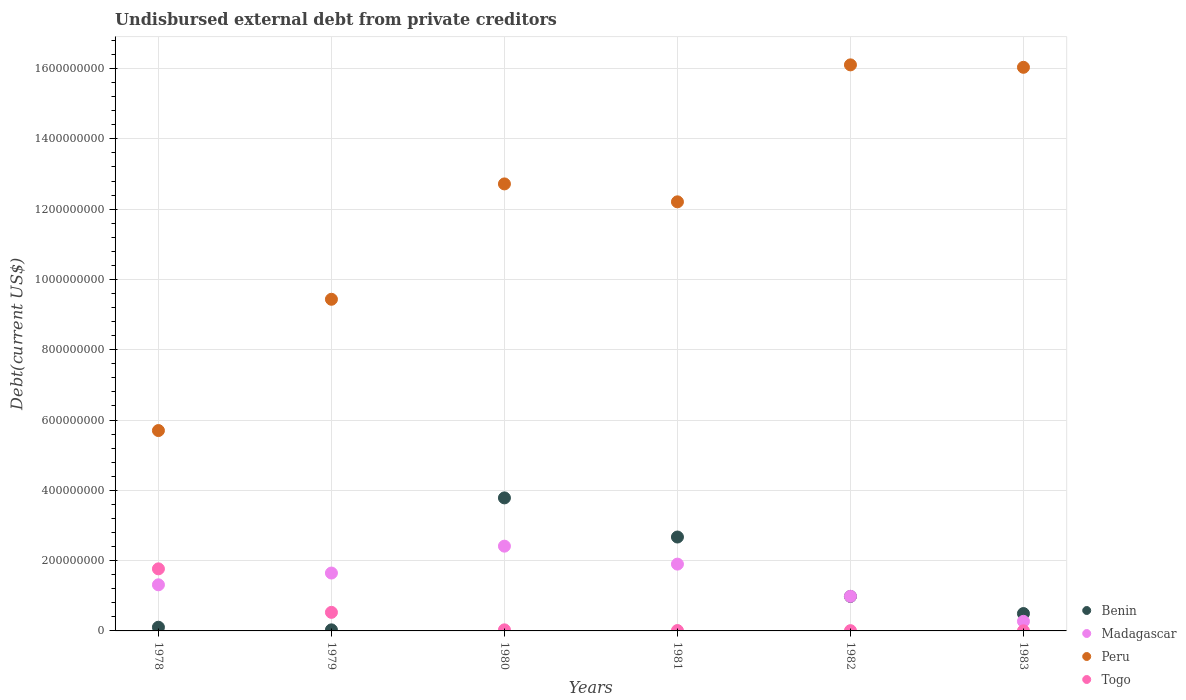How many different coloured dotlines are there?
Give a very brief answer. 4. What is the total debt in Togo in 1978?
Your answer should be compact. 1.77e+08. Across all years, what is the maximum total debt in Benin?
Your response must be concise. 3.78e+08. Across all years, what is the minimum total debt in Peru?
Your answer should be very brief. 5.70e+08. In which year was the total debt in Togo maximum?
Make the answer very short. 1978. In which year was the total debt in Madagascar minimum?
Offer a very short reply. 1983. What is the total total debt in Togo in the graph?
Offer a terse response. 2.35e+08. What is the difference between the total debt in Peru in 1979 and that in 1981?
Give a very brief answer. -2.77e+08. What is the difference between the total debt in Madagascar in 1983 and the total debt in Benin in 1981?
Your response must be concise. -2.40e+08. What is the average total debt in Benin per year?
Your response must be concise. 1.34e+08. In the year 1982, what is the difference between the total debt in Togo and total debt in Peru?
Make the answer very short. -1.61e+09. In how many years, is the total debt in Togo greater than 40000000 US$?
Offer a terse response. 2. What is the ratio of the total debt in Peru in 1978 to that in 1981?
Ensure brevity in your answer.  0.47. Is the total debt in Togo in 1978 less than that in 1979?
Offer a very short reply. No. Is the difference between the total debt in Togo in 1979 and 1983 greater than the difference between the total debt in Peru in 1979 and 1983?
Provide a short and direct response. Yes. What is the difference between the highest and the second highest total debt in Togo?
Your answer should be compact. 1.24e+08. What is the difference between the highest and the lowest total debt in Benin?
Offer a very short reply. 3.75e+08. Is the sum of the total debt in Madagascar in 1978 and 1982 greater than the maximum total debt in Peru across all years?
Ensure brevity in your answer.  No. Is it the case that in every year, the sum of the total debt in Madagascar and total debt in Togo  is greater than the sum of total debt in Peru and total debt in Benin?
Offer a terse response. No. Is it the case that in every year, the sum of the total debt in Togo and total debt in Madagascar  is greater than the total debt in Peru?
Your response must be concise. No. Is the total debt in Togo strictly less than the total debt in Madagascar over the years?
Offer a very short reply. No. What is the difference between two consecutive major ticks on the Y-axis?
Offer a very short reply. 2.00e+08. Are the values on the major ticks of Y-axis written in scientific E-notation?
Your response must be concise. No. How are the legend labels stacked?
Provide a succinct answer. Vertical. What is the title of the graph?
Your answer should be very brief. Undisbursed external debt from private creditors. What is the label or title of the Y-axis?
Your answer should be very brief. Debt(current US$). What is the Debt(current US$) in Benin in 1978?
Offer a very short reply. 1.05e+07. What is the Debt(current US$) in Madagascar in 1978?
Your answer should be very brief. 1.31e+08. What is the Debt(current US$) in Peru in 1978?
Your answer should be very brief. 5.70e+08. What is the Debt(current US$) of Togo in 1978?
Your answer should be very brief. 1.77e+08. What is the Debt(current US$) of Benin in 1979?
Offer a terse response. 3.05e+06. What is the Debt(current US$) in Madagascar in 1979?
Your response must be concise. 1.65e+08. What is the Debt(current US$) in Peru in 1979?
Provide a succinct answer. 9.44e+08. What is the Debt(current US$) in Togo in 1979?
Give a very brief answer. 5.28e+07. What is the Debt(current US$) of Benin in 1980?
Your answer should be very brief. 3.78e+08. What is the Debt(current US$) of Madagascar in 1980?
Make the answer very short. 2.41e+08. What is the Debt(current US$) in Peru in 1980?
Provide a short and direct response. 1.27e+09. What is the Debt(current US$) in Togo in 1980?
Offer a terse response. 3.05e+06. What is the Debt(current US$) in Benin in 1981?
Keep it short and to the point. 2.67e+08. What is the Debt(current US$) in Madagascar in 1981?
Give a very brief answer. 1.90e+08. What is the Debt(current US$) in Peru in 1981?
Your answer should be very brief. 1.22e+09. What is the Debt(current US$) in Togo in 1981?
Make the answer very short. 1.08e+06. What is the Debt(current US$) in Benin in 1982?
Provide a short and direct response. 9.81e+07. What is the Debt(current US$) of Madagascar in 1982?
Your response must be concise. 9.86e+07. What is the Debt(current US$) in Peru in 1982?
Your answer should be compact. 1.61e+09. What is the Debt(current US$) of Togo in 1982?
Keep it short and to the point. 7.35e+05. What is the Debt(current US$) in Benin in 1983?
Your response must be concise. 4.94e+07. What is the Debt(current US$) in Madagascar in 1983?
Give a very brief answer. 2.73e+07. What is the Debt(current US$) of Peru in 1983?
Ensure brevity in your answer.  1.60e+09. What is the Debt(current US$) in Togo in 1983?
Your answer should be very brief. 3.03e+05. Across all years, what is the maximum Debt(current US$) in Benin?
Provide a short and direct response. 3.78e+08. Across all years, what is the maximum Debt(current US$) of Madagascar?
Your answer should be very brief. 2.41e+08. Across all years, what is the maximum Debt(current US$) of Peru?
Offer a very short reply. 1.61e+09. Across all years, what is the maximum Debt(current US$) of Togo?
Your response must be concise. 1.77e+08. Across all years, what is the minimum Debt(current US$) in Benin?
Offer a very short reply. 3.05e+06. Across all years, what is the minimum Debt(current US$) in Madagascar?
Your answer should be very brief. 2.73e+07. Across all years, what is the minimum Debt(current US$) in Peru?
Your response must be concise. 5.70e+08. Across all years, what is the minimum Debt(current US$) in Togo?
Keep it short and to the point. 3.03e+05. What is the total Debt(current US$) of Benin in the graph?
Your answer should be compact. 8.07e+08. What is the total Debt(current US$) of Madagascar in the graph?
Your response must be concise. 8.53e+08. What is the total Debt(current US$) in Peru in the graph?
Give a very brief answer. 7.22e+09. What is the total Debt(current US$) in Togo in the graph?
Ensure brevity in your answer.  2.35e+08. What is the difference between the Debt(current US$) of Benin in 1978 and that in 1979?
Keep it short and to the point. 7.45e+06. What is the difference between the Debt(current US$) of Madagascar in 1978 and that in 1979?
Ensure brevity in your answer.  -3.35e+07. What is the difference between the Debt(current US$) in Peru in 1978 and that in 1979?
Your response must be concise. -3.73e+08. What is the difference between the Debt(current US$) of Togo in 1978 and that in 1979?
Keep it short and to the point. 1.24e+08. What is the difference between the Debt(current US$) in Benin in 1978 and that in 1980?
Provide a short and direct response. -3.68e+08. What is the difference between the Debt(current US$) of Madagascar in 1978 and that in 1980?
Make the answer very short. -1.10e+08. What is the difference between the Debt(current US$) of Peru in 1978 and that in 1980?
Your answer should be very brief. -7.02e+08. What is the difference between the Debt(current US$) of Togo in 1978 and that in 1980?
Make the answer very short. 1.74e+08. What is the difference between the Debt(current US$) of Benin in 1978 and that in 1981?
Make the answer very short. -2.57e+08. What is the difference between the Debt(current US$) in Madagascar in 1978 and that in 1981?
Keep it short and to the point. -5.89e+07. What is the difference between the Debt(current US$) in Peru in 1978 and that in 1981?
Ensure brevity in your answer.  -6.51e+08. What is the difference between the Debt(current US$) in Togo in 1978 and that in 1981?
Make the answer very short. 1.76e+08. What is the difference between the Debt(current US$) in Benin in 1978 and that in 1982?
Your answer should be compact. -8.76e+07. What is the difference between the Debt(current US$) in Madagascar in 1978 and that in 1982?
Offer a very short reply. 3.26e+07. What is the difference between the Debt(current US$) in Peru in 1978 and that in 1982?
Ensure brevity in your answer.  -1.04e+09. What is the difference between the Debt(current US$) in Togo in 1978 and that in 1982?
Give a very brief answer. 1.76e+08. What is the difference between the Debt(current US$) of Benin in 1978 and that in 1983?
Your answer should be very brief. -3.89e+07. What is the difference between the Debt(current US$) of Madagascar in 1978 and that in 1983?
Your answer should be very brief. 1.04e+08. What is the difference between the Debt(current US$) of Peru in 1978 and that in 1983?
Keep it short and to the point. -1.03e+09. What is the difference between the Debt(current US$) in Togo in 1978 and that in 1983?
Your response must be concise. 1.76e+08. What is the difference between the Debt(current US$) of Benin in 1979 and that in 1980?
Your answer should be very brief. -3.75e+08. What is the difference between the Debt(current US$) in Madagascar in 1979 and that in 1980?
Offer a very short reply. -7.65e+07. What is the difference between the Debt(current US$) in Peru in 1979 and that in 1980?
Ensure brevity in your answer.  -3.28e+08. What is the difference between the Debt(current US$) in Togo in 1979 and that in 1980?
Ensure brevity in your answer.  4.98e+07. What is the difference between the Debt(current US$) of Benin in 1979 and that in 1981?
Keep it short and to the point. -2.64e+08. What is the difference between the Debt(current US$) of Madagascar in 1979 and that in 1981?
Provide a succinct answer. -2.54e+07. What is the difference between the Debt(current US$) of Peru in 1979 and that in 1981?
Give a very brief answer. -2.77e+08. What is the difference between the Debt(current US$) in Togo in 1979 and that in 1981?
Keep it short and to the point. 5.18e+07. What is the difference between the Debt(current US$) in Benin in 1979 and that in 1982?
Offer a very short reply. -9.50e+07. What is the difference between the Debt(current US$) of Madagascar in 1979 and that in 1982?
Your answer should be compact. 6.61e+07. What is the difference between the Debt(current US$) of Peru in 1979 and that in 1982?
Your answer should be very brief. -6.67e+08. What is the difference between the Debt(current US$) in Togo in 1979 and that in 1982?
Your response must be concise. 5.21e+07. What is the difference between the Debt(current US$) in Benin in 1979 and that in 1983?
Your response must be concise. -4.64e+07. What is the difference between the Debt(current US$) of Madagascar in 1979 and that in 1983?
Offer a very short reply. 1.37e+08. What is the difference between the Debt(current US$) of Peru in 1979 and that in 1983?
Make the answer very short. -6.60e+08. What is the difference between the Debt(current US$) in Togo in 1979 and that in 1983?
Provide a succinct answer. 5.25e+07. What is the difference between the Debt(current US$) in Benin in 1980 and that in 1981?
Give a very brief answer. 1.11e+08. What is the difference between the Debt(current US$) in Madagascar in 1980 and that in 1981?
Your answer should be very brief. 5.11e+07. What is the difference between the Debt(current US$) in Peru in 1980 and that in 1981?
Offer a very short reply. 5.10e+07. What is the difference between the Debt(current US$) of Togo in 1980 and that in 1981?
Provide a succinct answer. 1.98e+06. What is the difference between the Debt(current US$) in Benin in 1980 and that in 1982?
Ensure brevity in your answer.  2.80e+08. What is the difference between the Debt(current US$) of Madagascar in 1980 and that in 1982?
Make the answer very short. 1.43e+08. What is the difference between the Debt(current US$) in Peru in 1980 and that in 1982?
Keep it short and to the point. -3.39e+08. What is the difference between the Debt(current US$) of Togo in 1980 and that in 1982?
Offer a very short reply. 2.32e+06. What is the difference between the Debt(current US$) of Benin in 1980 and that in 1983?
Provide a succinct answer. 3.29e+08. What is the difference between the Debt(current US$) of Madagascar in 1980 and that in 1983?
Provide a short and direct response. 2.14e+08. What is the difference between the Debt(current US$) of Peru in 1980 and that in 1983?
Offer a very short reply. -3.32e+08. What is the difference between the Debt(current US$) of Togo in 1980 and that in 1983?
Give a very brief answer. 2.75e+06. What is the difference between the Debt(current US$) in Benin in 1981 and that in 1982?
Make the answer very short. 1.69e+08. What is the difference between the Debt(current US$) of Madagascar in 1981 and that in 1982?
Offer a terse response. 9.15e+07. What is the difference between the Debt(current US$) in Peru in 1981 and that in 1982?
Your answer should be compact. -3.90e+08. What is the difference between the Debt(current US$) in Togo in 1981 and that in 1982?
Make the answer very short. 3.42e+05. What is the difference between the Debt(current US$) in Benin in 1981 and that in 1983?
Make the answer very short. 2.18e+08. What is the difference between the Debt(current US$) in Madagascar in 1981 and that in 1983?
Keep it short and to the point. 1.63e+08. What is the difference between the Debt(current US$) of Peru in 1981 and that in 1983?
Provide a short and direct response. -3.83e+08. What is the difference between the Debt(current US$) in Togo in 1981 and that in 1983?
Keep it short and to the point. 7.74e+05. What is the difference between the Debt(current US$) in Benin in 1982 and that in 1983?
Your answer should be very brief. 4.87e+07. What is the difference between the Debt(current US$) of Madagascar in 1982 and that in 1983?
Your response must be concise. 7.13e+07. What is the difference between the Debt(current US$) of Peru in 1982 and that in 1983?
Offer a terse response. 6.94e+06. What is the difference between the Debt(current US$) of Togo in 1982 and that in 1983?
Your answer should be compact. 4.32e+05. What is the difference between the Debt(current US$) in Benin in 1978 and the Debt(current US$) in Madagascar in 1979?
Offer a very short reply. -1.54e+08. What is the difference between the Debt(current US$) in Benin in 1978 and the Debt(current US$) in Peru in 1979?
Your answer should be compact. -9.33e+08. What is the difference between the Debt(current US$) in Benin in 1978 and the Debt(current US$) in Togo in 1979?
Provide a short and direct response. -4.23e+07. What is the difference between the Debt(current US$) in Madagascar in 1978 and the Debt(current US$) in Peru in 1979?
Provide a short and direct response. -8.12e+08. What is the difference between the Debt(current US$) of Madagascar in 1978 and the Debt(current US$) of Togo in 1979?
Offer a terse response. 7.84e+07. What is the difference between the Debt(current US$) in Peru in 1978 and the Debt(current US$) in Togo in 1979?
Your response must be concise. 5.17e+08. What is the difference between the Debt(current US$) of Benin in 1978 and the Debt(current US$) of Madagascar in 1980?
Ensure brevity in your answer.  -2.31e+08. What is the difference between the Debt(current US$) in Benin in 1978 and the Debt(current US$) in Peru in 1980?
Your answer should be compact. -1.26e+09. What is the difference between the Debt(current US$) of Benin in 1978 and the Debt(current US$) of Togo in 1980?
Your response must be concise. 7.44e+06. What is the difference between the Debt(current US$) in Madagascar in 1978 and the Debt(current US$) in Peru in 1980?
Keep it short and to the point. -1.14e+09. What is the difference between the Debt(current US$) of Madagascar in 1978 and the Debt(current US$) of Togo in 1980?
Give a very brief answer. 1.28e+08. What is the difference between the Debt(current US$) in Peru in 1978 and the Debt(current US$) in Togo in 1980?
Ensure brevity in your answer.  5.67e+08. What is the difference between the Debt(current US$) in Benin in 1978 and the Debt(current US$) in Madagascar in 1981?
Make the answer very short. -1.80e+08. What is the difference between the Debt(current US$) in Benin in 1978 and the Debt(current US$) in Peru in 1981?
Offer a terse response. -1.21e+09. What is the difference between the Debt(current US$) of Benin in 1978 and the Debt(current US$) of Togo in 1981?
Your answer should be very brief. 9.42e+06. What is the difference between the Debt(current US$) in Madagascar in 1978 and the Debt(current US$) in Peru in 1981?
Make the answer very short. -1.09e+09. What is the difference between the Debt(current US$) in Madagascar in 1978 and the Debt(current US$) in Togo in 1981?
Give a very brief answer. 1.30e+08. What is the difference between the Debt(current US$) in Peru in 1978 and the Debt(current US$) in Togo in 1981?
Ensure brevity in your answer.  5.69e+08. What is the difference between the Debt(current US$) of Benin in 1978 and the Debt(current US$) of Madagascar in 1982?
Your answer should be compact. -8.81e+07. What is the difference between the Debt(current US$) in Benin in 1978 and the Debt(current US$) in Peru in 1982?
Your answer should be compact. -1.60e+09. What is the difference between the Debt(current US$) in Benin in 1978 and the Debt(current US$) in Togo in 1982?
Your response must be concise. 9.76e+06. What is the difference between the Debt(current US$) in Madagascar in 1978 and the Debt(current US$) in Peru in 1982?
Make the answer very short. -1.48e+09. What is the difference between the Debt(current US$) in Madagascar in 1978 and the Debt(current US$) in Togo in 1982?
Ensure brevity in your answer.  1.30e+08. What is the difference between the Debt(current US$) in Peru in 1978 and the Debt(current US$) in Togo in 1982?
Give a very brief answer. 5.69e+08. What is the difference between the Debt(current US$) of Benin in 1978 and the Debt(current US$) of Madagascar in 1983?
Provide a succinct answer. -1.68e+07. What is the difference between the Debt(current US$) in Benin in 1978 and the Debt(current US$) in Peru in 1983?
Offer a very short reply. -1.59e+09. What is the difference between the Debt(current US$) in Benin in 1978 and the Debt(current US$) in Togo in 1983?
Provide a short and direct response. 1.02e+07. What is the difference between the Debt(current US$) in Madagascar in 1978 and the Debt(current US$) in Peru in 1983?
Your response must be concise. -1.47e+09. What is the difference between the Debt(current US$) of Madagascar in 1978 and the Debt(current US$) of Togo in 1983?
Keep it short and to the point. 1.31e+08. What is the difference between the Debt(current US$) in Peru in 1978 and the Debt(current US$) in Togo in 1983?
Keep it short and to the point. 5.70e+08. What is the difference between the Debt(current US$) of Benin in 1979 and the Debt(current US$) of Madagascar in 1980?
Provide a short and direct response. -2.38e+08. What is the difference between the Debt(current US$) in Benin in 1979 and the Debt(current US$) in Peru in 1980?
Offer a terse response. -1.27e+09. What is the difference between the Debt(current US$) in Benin in 1979 and the Debt(current US$) in Togo in 1980?
Give a very brief answer. -6000. What is the difference between the Debt(current US$) in Madagascar in 1979 and the Debt(current US$) in Peru in 1980?
Keep it short and to the point. -1.11e+09. What is the difference between the Debt(current US$) of Madagascar in 1979 and the Debt(current US$) of Togo in 1980?
Your answer should be compact. 1.62e+08. What is the difference between the Debt(current US$) of Peru in 1979 and the Debt(current US$) of Togo in 1980?
Offer a very short reply. 9.41e+08. What is the difference between the Debt(current US$) of Benin in 1979 and the Debt(current US$) of Madagascar in 1981?
Offer a terse response. -1.87e+08. What is the difference between the Debt(current US$) of Benin in 1979 and the Debt(current US$) of Peru in 1981?
Provide a short and direct response. -1.22e+09. What is the difference between the Debt(current US$) of Benin in 1979 and the Debt(current US$) of Togo in 1981?
Your answer should be very brief. 1.97e+06. What is the difference between the Debt(current US$) of Madagascar in 1979 and the Debt(current US$) of Peru in 1981?
Offer a very short reply. -1.06e+09. What is the difference between the Debt(current US$) of Madagascar in 1979 and the Debt(current US$) of Togo in 1981?
Provide a short and direct response. 1.64e+08. What is the difference between the Debt(current US$) of Peru in 1979 and the Debt(current US$) of Togo in 1981?
Keep it short and to the point. 9.42e+08. What is the difference between the Debt(current US$) of Benin in 1979 and the Debt(current US$) of Madagascar in 1982?
Make the answer very short. -9.55e+07. What is the difference between the Debt(current US$) in Benin in 1979 and the Debt(current US$) in Peru in 1982?
Make the answer very short. -1.61e+09. What is the difference between the Debt(current US$) of Benin in 1979 and the Debt(current US$) of Togo in 1982?
Offer a very short reply. 2.31e+06. What is the difference between the Debt(current US$) in Madagascar in 1979 and the Debt(current US$) in Peru in 1982?
Keep it short and to the point. -1.45e+09. What is the difference between the Debt(current US$) of Madagascar in 1979 and the Debt(current US$) of Togo in 1982?
Ensure brevity in your answer.  1.64e+08. What is the difference between the Debt(current US$) in Peru in 1979 and the Debt(current US$) in Togo in 1982?
Offer a terse response. 9.43e+08. What is the difference between the Debt(current US$) of Benin in 1979 and the Debt(current US$) of Madagascar in 1983?
Offer a very short reply. -2.42e+07. What is the difference between the Debt(current US$) of Benin in 1979 and the Debt(current US$) of Peru in 1983?
Make the answer very short. -1.60e+09. What is the difference between the Debt(current US$) of Benin in 1979 and the Debt(current US$) of Togo in 1983?
Offer a very short reply. 2.74e+06. What is the difference between the Debt(current US$) of Madagascar in 1979 and the Debt(current US$) of Peru in 1983?
Make the answer very short. -1.44e+09. What is the difference between the Debt(current US$) in Madagascar in 1979 and the Debt(current US$) in Togo in 1983?
Offer a terse response. 1.64e+08. What is the difference between the Debt(current US$) of Peru in 1979 and the Debt(current US$) of Togo in 1983?
Your response must be concise. 9.43e+08. What is the difference between the Debt(current US$) in Benin in 1980 and the Debt(current US$) in Madagascar in 1981?
Make the answer very short. 1.88e+08. What is the difference between the Debt(current US$) in Benin in 1980 and the Debt(current US$) in Peru in 1981?
Keep it short and to the point. -8.42e+08. What is the difference between the Debt(current US$) of Benin in 1980 and the Debt(current US$) of Togo in 1981?
Offer a very short reply. 3.77e+08. What is the difference between the Debt(current US$) of Madagascar in 1980 and the Debt(current US$) of Peru in 1981?
Your answer should be compact. -9.80e+08. What is the difference between the Debt(current US$) in Madagascar in 1980 and the Debt(current US$) in Togo in 1981?
Make the answer very short. 2.40e+08. What is the difference between the Debt(current US$) of Peru in 1980 and the Debt(current US$) of Togo in 1981?
Offer a terse response. 1.27e+09. What is the difference between the Debt(current US$) of Benin in 1980 and the Debt(current US$) of Madagascar in 1982?
Offer a terse response. 2.80e+08. What is the difference between the Debt(current US$) in Benin in 1980 and the Debt(current US$) in Peru in 1982?
Ensure brevity in your answer.  -1.23e+09. What is the difference between the Debt(current US$) in Benin in 1980 and the Debt(current US$) in Togo in 1982?
Ensure brevity in your answer.  3.78e+08. What is the difference between the Debt(current US$) of Madagascar in 1980 and the Debt(current US$) of Peru in 1982?
Make the answer very short. -1.37e+09. What is the difference between the Debt(current US$) of Madagascar in 1980 and the Debt(current US$) of Togo in 1982?
Your answer should be very brief. 2.40e+08. What is the difference between the Debt(current US$) in Peru in 1980 and the Debt(current US$) in Togo in 1982?
Provide a short and direct response. 1.27e+09. What is the difference between the Debt(current US$) in Benin in 1980 and the Debt(current US$) in Madagascar in 1983?
Provide a succinct answer. 3.51e+08. What is the difference between the Debt(current US$) in Benin in 1980 and the Debt(current US$) in Peru in 1983?
Your response must be concise. -1.23e+09. What is the difference between the Debt(current US$) in Benin in 1980 and the Debt(current US$) in Togo in 1983?
Ensure brevity in your answer.  3.78e+08. What is the difference between the Debt(current US$) in Madagascar in 1980 and the Debt(current US$) in Peru in 1983?
Your response must be concise. -1.36e+09. What is the difference between the Debt(current US$) of Madagascar in 1980 and the Debt(current US$) of Togo in 1983?
Your answer should be very brief. 2.41e+08. What is the difference between the Debt(current US$) in Peru in 1980 and the Debt(current US$) in Togo in 1983?
Give a very brief answer. 1.27e+09. What is the difference between the Debt(current US$) of Benin in 1981 and the Debt(current US$) of Madagascar in 1982?
Make the answer very short. 1.69e+08. What is the difference between the Debt(current US$) of Benin in 1981 and the Debt(current US$) of Peru in 1982?
Offer a terse response. -1.34e+09. What is the difference between the Debt(current US$) in Benin in 1981 and the Debt(current US$) in Togo in 1982?
Provide a succinct answer. 2.66e+08. What is the difference between the Debt(current US$) in Madagascar in 1981 and the Debt(current US$) in Peru in 1982?
Make the answer very short. -1.42e+09. What is the difference between the Debt(current US$) in Madagascar in 1981 and the Debt(current US$) in Togo in 1982?
Your response must be concise. 1.89e+08. What is the difference between the Debt(current US$) in Peru in 1981 and the Debt(current US$) in Togo in 1982?
Provide a short and direct response. 1.22e+09. What is the difference between the Debt(current US$) in Benin in 1981 and the Debt(current US$) in Madagascar in 1983?
Provide a short and direct response. 2.40e+08. What is the difference between the Debt(current US$) in Benin in 1981 and the Debt(current US$) in Peru in 1983?
Make the answer very short. -1.34e+09. What is the difference between the Debt(current US$) in Benin in 1981 and the Debt(current US$) in Togo in 1983?
Make the answer very short. 2.67e+08. What is the difference between the Debt(current US$) of Madagascar in 1981 and the Debt(current US$) of Peru in 1983?
Your answer should be very brief. -1.41e+09. What is the difference between the Debt(current US$) in Madagascar in 1981 and the Debt(current US$) in Togo in 1983?
Provide a succinct answer. 1.90e+08. What is the difference between the Debt(current US$) in Peru in 1981 and the Debt(current US$) in Togo in 1983?
Keep it short and to the point. 1.22e+09. What is the difference between the Debt(current US$) of Benin in 1982 and the Debt(current US$) of Madagascar in 1983?
Your answer should be compact. 7.08e+07. What is the difference between the Debt(current US$) in Benin in 1982 and the Debt(current US$) in Peru in 1983?
Make the answer very short. -1.51e+09. What is the difference between the Debt(current US$) of Benin in 1982 and the Debt(current US$) of Togo in 1983?
Keep it short and to the point. 9.78e+07. What is the difference between the Debt(current US$) of Madagascar in 1982 and the Debt(current US$) of Peru in 1983?
Give a very brief answer. -1.50e+09. What is the difference between the Debt(current US$) of Madagascar in 1982 and the Debt(current US$) of Togo in 1983?
Provide a short and direct response. 9.82e+07. What is the difference between the Debt(current US$) in Peru in 1982 and the Debt(current US$) in Togo in 1983?
Provide a short and direct response. 1.61e+09. What is the average Debt(current US$) of Benin per year?
Provide a succinct answer. 1.34e+08. What is the average Debt(current US$) of Madagascar per year?
Your answer should be compact. 1.42e+08. What is the average Debt(current US$) in Peru per year?
Provide a succinct answer. 1.20e+09. What is the average Debt(current US$) of Togo per year?
Provide a short and direct response. 3.91e+07. In the year 1978, what is the difference between the Debt(current US$) in Benin and Debt(current US$) in Madagascar?
Your answer should be compact. -1.21e+08. In the year 1978, what is the difference between the Debt(current US$) of Benin and Debt(current US$) of Peru?
Your answer should be compact. -5.60e+08. In the year 1978, what is the difference between the Debt(current US$) of Benin and Debt(current US$) of Togo?
Keep it short and to the point. -1.66e+08. In the year 1978, what is the difference between the Debt(current US$) in Madagascar and Debt(current US$) in Peru?
Your answer should be very brief. -4.39e+08. In the year 1978, what is the difference between the Debt(current US$) of Madagascar and Debt(current US$) of Togo?
Provide a short and direct response. -4.54e+07. In the year 1978, what is the difference between the Debt(current US$) of Peru and Debt(current US$) of Togo?
Make the answer very short. 3.93e+08. In the year 1979, what is the difference between the Debt(current US$) in Benin and Debt(current US$) in Madagascar?
Offer a very short reply. -1.62e+08. In the year 1979, what is the difference between the Debt(current US$) of Benin and Debt(current US$) of Peru?
Make the answer very short. -9.41e+08. In the year 1979, what is the difference between the Debt(current US$) of Benin and Debt(current US$) of Togo?
Offer a terse response. -4.98e+07. In the year 1979, what is the difference between the Debt(current US$) in Madagascar and Debt(current US$) in Peru?
Your answer should be compact. -7.79e+08. In the year 1979, what is the difference between the Debt(current US$) in Madagascar and Debt(current US$) in Togo?
Your answer should be compact. 1.12e+08. In the year 1979, what is the difference between the Debt(current US$) of Peru and Debt(current US$) of Togo?
Your response must be concise. 8.91e+08. In the year 1980, what is the difference between the Debt(current US$) in Benin and Debt(current US$) in Madagascar?
Offer a very short reply. 1.37e+08. In the year 1980, what is the difference between the Debt(current US$) of Benin and Debt(current US$) of Peru?
Your answer should be compact. -8.93e+08. In the year 1980, what is the difference between the Debt(current US$) of Benin and Debt(current US$) of Togo?
Ensure brevity in your answer.  3.75e+08. In the year 1980, what is the difference between the Debt(current US$) of Madagascar and Debt(current US$) of Peru?
Offer a terse response. -1.03e+09. In the year 1980, what is the difference between the Debt(current US$) of Madagascar and Debt(current US$) of Togo?
Keep it short and to the point. 2.38e+08. In the year 1980, what is the difference between the Debt(current US$) in Peru and Debt(current US$) in Togo?
Keep it short and to the point. 1.27e+09. In the year 1981, what is the difference between the Debt(current US$) of Benin and Debt(current US$) of Madagascar?
Offer a very short reply. 7.71e+07. In the year 1981, what is the difference between the Debt(current US$) of Benin and Debt(current US$) of Peru?
Your answer should be compact. -9.54e+08. In the year 1981, what is the difference between the Debt(current US$) of Benin and Debt(current US$) of Togo?
Your response must be concise. 2.66e+08. In the year 1981, what is the difference between the Debt(current US$) in Madagascar and Debt(current US$) in Peru?
Keep it short and to the point. -1.03e+09. In the year 1981, what is the difference between the Debt(current US$) in Madagascar and Debt(current US$) in Togo?
Your answer should be compact. 1.89e+08. In the year 1981, what is the difference between the Debt(current US$) of Peru and Debt(current US$) of Togo?
Your answer should be very brief. 1.22e+09. In the year 1982, what is the difference between the Debt(current US$) in Benin and Debt(current US$) in Madagascar?
Offer a terse response. -4.56e+05. In the year 1982, what is the difference between the Debt(current US$) of Benin and Debt(current US$) of Peru?
Your response must be concise. -1.51e+09. In the year 1982, what is the difference between the Debt(current US$) in Benin and Debt(current US$) in Togo?
Make the answer very short. 9.74e+07. In the year 1982, what is the difference between the Debt(current US$) in Madagascar and Debt(current US$) in Peru?
Keep it short and to the point. -1.51e+09. In the year 1982, what is the difference between the Debt(current US$) of Madagascar and Debt(current US$) of Togo?
Your response must be concise. 9.78e+07. In the year 1982, what is the difference between the Debt(current US$) of Peru and Debt(current US$) of Togo?
Keep it short and to the point. 1.61e+09. In the year 1983, what is the difference between the Debt(current US$) of Benin and Debt(current US$) of Madagascar?
Provide a short and direct response. 2.22e+07. In the year 1983, what is the difference between the Debt(current US$) in Benin and Debt(current US$) in Peru?
Your answer should be compact. -1.55e+09. In the year 1983, what is the difference between the Debt(current US$) of Benin and Debt(current US$) of Togo?
Give a very brief answer. 4.91e+07. In the year 1983, what is the difference between the Debt(current US$) of Madagascar and Debt(current US$) of Peru?
Your response must be concise. -1.58e+09. In the year 1983, what is the difference between the Debt(current US$) in Madagascar and Debt(current US$) in Togo?
Your response must be concise. 2.70e+07. In the year 1983, what is the difference between the Debt(current US$) in Peru and Debt(current US$) in Togo?
Provide a short and direct response. 1.60e+09. What is the ratio of the Debt(current US$) of Benin in 1978 to that in 1979?
Ensure brevity in your answer.  3.44. What is the ratio of the Debt(current US$) in Madagascar in 1978 to that in 1979?
Provide a short and direct response. 0.8. What is the ratio of the Debt(current US$) in Peru in 1978 to that in 1979?
Your answer should be very brief. 0.6. What is the ratio of the Debt(current US$) of Togo in 1978 to that in 1979?
Make the answer very short. 3.34. What is the ratio of the Debt(current US$) of Benin in 1978 to that in 1980?
Make the answer very short. 0.03. What is the ratio of the Debt(current US$) in Madagascar in 1978 to that in 1980?
Keep it short and to the point. 0.54. What is the ratio of the Debt(current US$) of Peru in 1978 to that in 1980?
Offer a very short reply. 0.45. What is the ratio of the Debt(current US$) in Togo in 1978 to that in 1980?
Provide a short and direct response. 57.83. What is the ratio of the Debt(current US$) in Benin in 1978 to that in 1981?
Provide a short and direct response. 0.04. What is the ratio of the Debt(current US$) of Madagascar in 1978 to that in 1981?
Offer a very short reply. 0.69. What is the ratio of the Debt(current US$) of Peru in 1978 to that in 1981?
Provide a short and direct response. 0.47. What is the ratio of the Debt(current US$) of Togo in 1978 to that in 1981?
Give a very brief answer. 163.97. What is the ratio of the Debt(current US$) of Benin in 1978 to that in 1982?
Offer a very short reply. 0.11. What is the ratio of the Debt(current US$) in Madagascar in 1978 to that in 1982?
Make the answer very short. 1.33. What is the ratio of the Debt(current US$) in Peru in 1978 to that in 1982?
Make the answer very short. 0.35. What is the ratio of the Debt(current US$) in Togo in 1978 to that in 1982?
Your answer should be compact. 240.27. What is the ratio of the Debt(current US$) in Benin in 1978 to that in 1983?
Make the answer very short. 0.21. What is the ratio of the Debt(current US$) in Madagascar in 1978 to that in 1983?
Offer a terse response. 4.81. What is the ratio of the Debt(current US$) in Peru in 1978 to that in 1983?
Your answer should be very brief. 0.36. What is the ratio of the Debt(current US$) in Togo in 1978 to that in 1983?
Your response must be concise. 582.83. What is the ratio of the Debt(current US$) of Benin in 1979 to that in 1980?
Provide a succinct answer. 0.01. What is the ratio of the Debt(current US$) of Madagascar in 1979 to that in 1980?
Ensure brevity in your answer.  0.68. What is the ratio of the Debt(current US$) in Peru in 1979 to that in 1980?
Provide a succinct answer. 0.74. What is the ratio of the Debt(current US$) in Togo in 1979 to that in 1980?
Keep it short and to the point. 17.3. What is the ratio of the Debt(current US$) of Benin in 1979 to that in 1981?
Your answer should be very brief. 0.01. What is the ratio of the Debt(current US$) in Madagascar in 1979 to that in 1981?
Your answer should be compact. 0.87. What is the ratio of the Debt(current US$) of Peru in 1979 to that in 1981?
Offer a very short reply. 0.77. What is the ratio of the Debt(current US$) of Togo in 1979 to that in 1981?
Offer a very short reply. 49.06. What is the ratio of the Debt(current US$) in Benin in 1979 to that in 1982?
Offer a very short reply. 0.03. What is the ratio of the Debt(current US$) in Madagascar in 1979 to that in 1982?
Keep it short and to the point. 1.67. What is the ratio of the Debt(current US$) in Peru in 1979 to that in 1982?
Make the answer very short. 0.59. What is the ratio of the Debt(current US$) in Togo in 1979 to that in 1982?
Keep it short and to the point. 71.89. What is the ratio of the Debt(current US$) in Benin in 1979 to that in 1983?
Make the answer very short. 0.06. What is the ratio of the Debt(current US$) of Madagascar in 1979 to that in 1983?
Offer a terse response. 6.04. What is the ratio of the Debt(current US$) of Peru in 1979 to that in 1983?
Keep it short and to the point. 0.59. What is the ratio of the Debt(current US$) in Togo in 1979 to that in 1983?
Keep it short and to the point. 174.39. What is the ratio of the Debt(current US$) in Benin in 1980 to that in 1981?
Make the answer very short. 1.42. What is the ratio of the Debt(current US$) of Madagascar in 1980 to that in 1981?
Make the answer very short. 1.27. What is the ratio of the Debt(current US$) of Peru in 1980 to that in 1981?
Your answer should be very brief. 1.04. What is the ratio of the Debt(current US$) in Togo in 1980 to that in 1981?
Offer a very short reply. 2.84. What is the ratio of the Debt(current US$) in Benin in 1980 to that in 1982?
Offer a terse response. 3.86. What is the ratio of the Debt(current US$) in Madagascar in 1980 to that in 1982?
Your answer should be compact. 2.45. What is the ratio of the Debt(current US$) in Peru in 1980 to that in 1982?
Your answer should be compact. 0.79. What is the ratio of the Debt(current US$) of Togo in 1980 to that in 1982?
Offer a very short reply. 4.16. What is the ratio of the Debt(current US$) of Benin in 1980 to that in 1983?
Your answer should be very brief. 7.66. What is the ratio of the Debt(current US$) of Madagascar in 1980 to that in 1983?
Give a very brief answer. 8.84. What is the ratio of the Debt(current US$) of Peru in 1980 to that in 1983?
Keep it short and to the point. 0.79. What is the ratio of the Debt(current US$) in Togo in 1980 to that in 1983?
Offer a very short reply. 10.08. What is the ratio of the Debt(current US$) of Benin in 1981 to that in 1982?
Keep it short and to the point. 2.72. What is the ratio of the Debt(current US$) of Madagascar in 1981 to that in 1982?
Your answer should be compact. 1.93. What is the ratio of the Debt(current US$) in Peru in 1981 to that in 1982?
Ensure brevity in your answer.  0.76. What is the ratio of the Debt(current US$) of Togo in 1981 to that in 1982?
Your answer should be compact. 1.47. What is the ratio of the Debt(current US$) in Benin in 1981 to that in 1983?
Make the answer very short. 5.41. What is the ratio of the Debt(current US$) in Madagascar in 1981 to that in 1983?
Make the answer very short. 6.97. What is the ratio of the Debt(current US$) in Peru in 1981 to that in 1983?
Keep it short and to the point. 0.76. What is the ratio of the Debt(current US$) in Togo in 1981 to that in 1983?
Give a very brief answer. 3.55. What is the ratio of the Debt(current US$) of Benin in 1982 to that in 1983?
Offer a terse response. 1.98. What is the ratio of the Debt(current US$) in Madagascar in 1982 to that in 1983?
Give a very brief answer. 3.61. What is the ratio of the Debt(current US$) in Peru in 1982 to that in 1983?
Give a very brief answer. 1. What is the ratio of the Debt(current US$) in Togo in 1982 to that in 1983?
Offer a very short reply. 2.43. What is the difference between the highest and the second highest Debt(current US$) in Benin?
Offer a very short reply. 1.11e+08. What is the difference between the highest and the second highest Debt(current US$) of Madagascar?
Offer a terse response. 5.11e+07. What is the difference between the highest and the second highest Debt(current US$) in Peru?
Your answer should be compact. 6.94e+06. What is the difference between the highest and the second highest Debt(current US$) in Togo?
Your response must be concise. 1.24e+08. What is the difference between the highest and the lowest Debt(current US$) of Benin?
Provide a short and direct response. 3.75e+08. What is the difference between the highest and the lowest Debt(current US$) of Madagascar?
Your answer should be compact. 2.14e+08. What is the difference between the highest and the lowest Debt(current US$) in Peru?
Your answer should be very brief. 1.04e+09. What is the difference between the highest and the lowest Debt(current US$) in Togo?
Provide a short and direct response. 1.76e+08. 